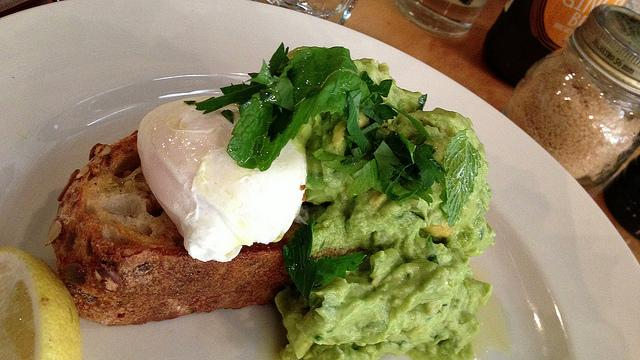What is the light green mixture?

Choices:
A) sauerkraut
B) salsa verde
C) guacamole
D) pesto guacamole 